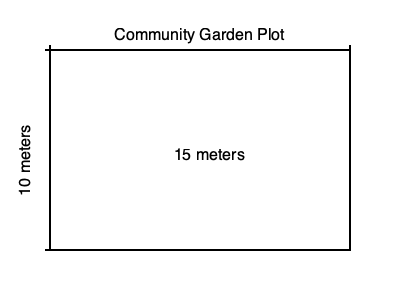A local community park is planning to create a rectangular garden plot for residents to grow vegetables. The plot measures 15 meters in length and 10 meters in width, as shown in the diagram. Calculate the total area of the garden plot in square meters. To calculate the area of a rectangular shape, we use the formula:

$$A = l \times w$$

Where:
$A$ = Area
$l$ = Length
$w$ = Width

Given:
Length ($l$) = 15 meters
Width ($w$) = 10 meters

Step 1: Substitute the values into the formula
$$A = 15 \text{ m} \times 10 \text{ m}$$

Step 2: Multiply the length and width
$$A = 150 \text{ m}^2$$

Therefore, the total area of the garden plot is 150 square meters.
Answer: $150 \text{ m}^2$ 